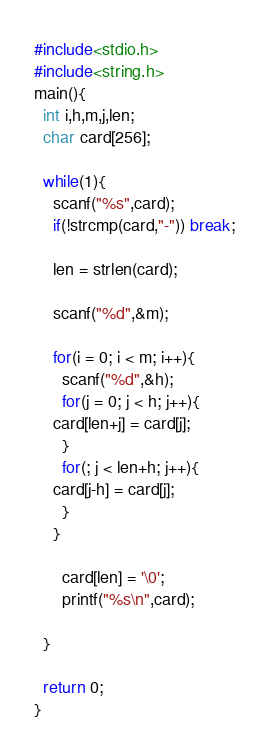<code> <loc_0><loc_0><loc_500><loc_500><_C_>#include<stdio.h>
#include<string.h>
main(){
  int i,h,m,j,len;
  char card[256];

  while(1){
    scanf("%s",card);
    if(!strcmp(card,"-")) break;

    len = strlen(card);

    scanf("%d",&m);

    for(i = 0; i < m; i++){
      scanf("%d",&h);
      for(j = 0; j < h; j++){
	card[len+j] = card[j];
      }
      for(; j < len+h; j++){
	card[j-h] = card[j];
      }
    }

      card[len] = '\0';
      printf("%s\n",card);

  }

  return 0;
}</code> 